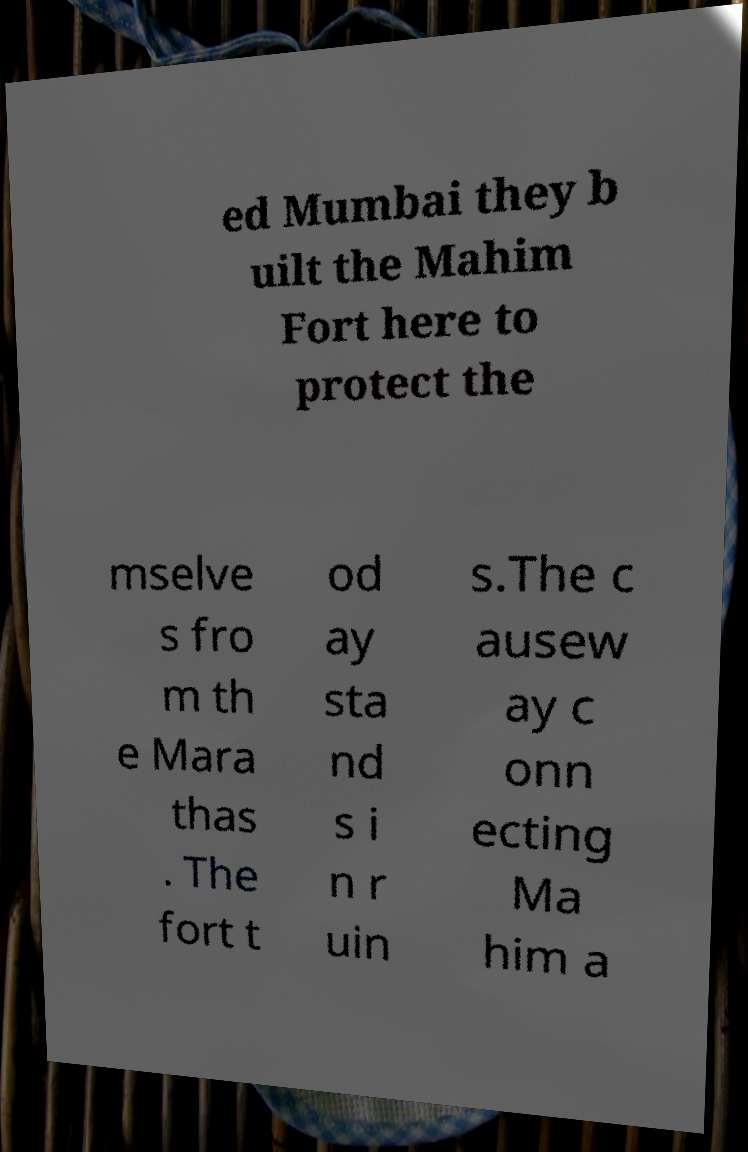For documentation purposes, I need the text within this image transcribed. Could you provide that? ed Mumbai they b uilt the Mahim Fort here to protect the mselve s fro m th e Mara thas . The fort t od ay sta nd s i n r uin s.The c ausew ay c onn ecting Ma him a 